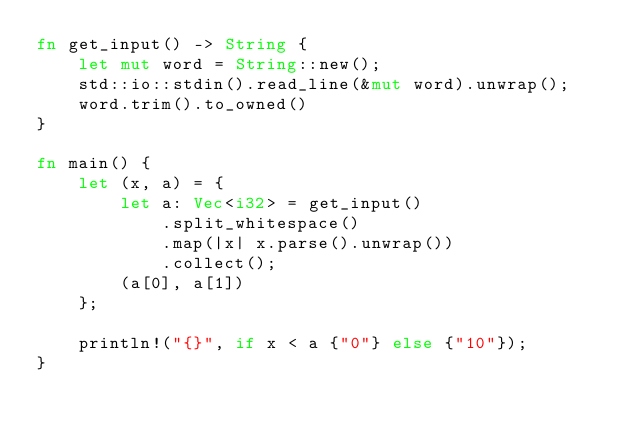<code> <loc_0><loc_0><loc_500><loc_500><_Rust_>fn get_input() -> String {
    let mut word = String::new();
    std::io::stdin().read_line(&mut word).unwrap();
    word.trim().to_owned()
}

fn main() {
    let (x, a) = {
        let a: Vec<i32> = get_input()
            .split_whitespace()
            .map(|x| x.parse().unwrap())
            .collect();
        (a[0], a[1])
    };

    println!("{}", if x < a {"0"} else {"10"});
}</code> 